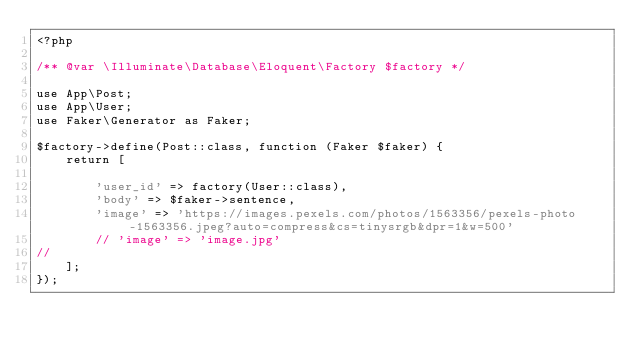Convert code to text. <code><loc_0><loc_0><loc_500><loc_500><_PHP_><?php

/** @var \Illuminate\Database\Eloquent\Factory $factory */

use App\Post;
use App\User;
use Faker\Generator as Faker;

$factory->define(Post::class, function (Faker $faker) {
    return [

        'user_id' => factory(User::class),
        'body' => $faker->sentence,
        'image' => 'https://images.pexels.com/photos/1563356/pexels-photo-1563356.jpeg?auto=compress&cs=tinysrgb&dpr=1&w=500'
        // 'image' => 'image.jpg'
// 
    ];
});
</code> 